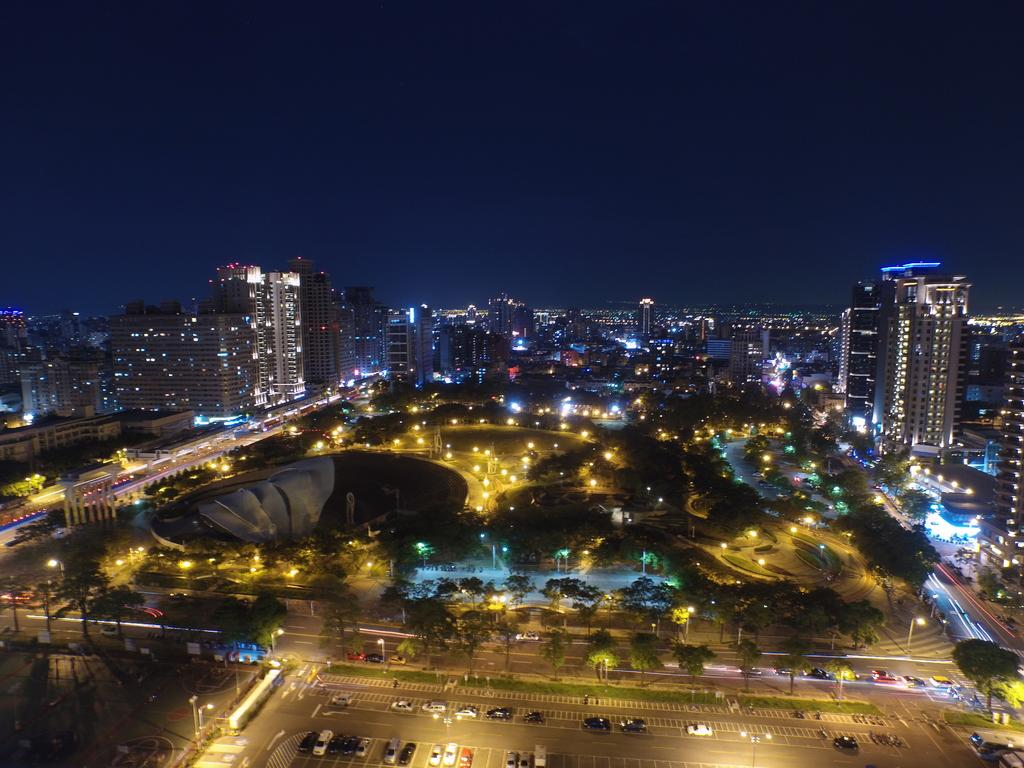What is the setting of the image? The image is a night view of a city. What structures can be seen in the image? There are buildings in the image. What type of transportation is present in the image? There are vehicles on the road in the image. What type of lighting is present in the image? There are street lights in the image. What type of vegetation is present in the image? There are trees in the image. What part of the natural environment is visible in the image? The sky is visible in the image. How many faucets can be seen in the image? There are no faucets present in the image. What type of boats are visible in the image? There are no boats present in the image. 